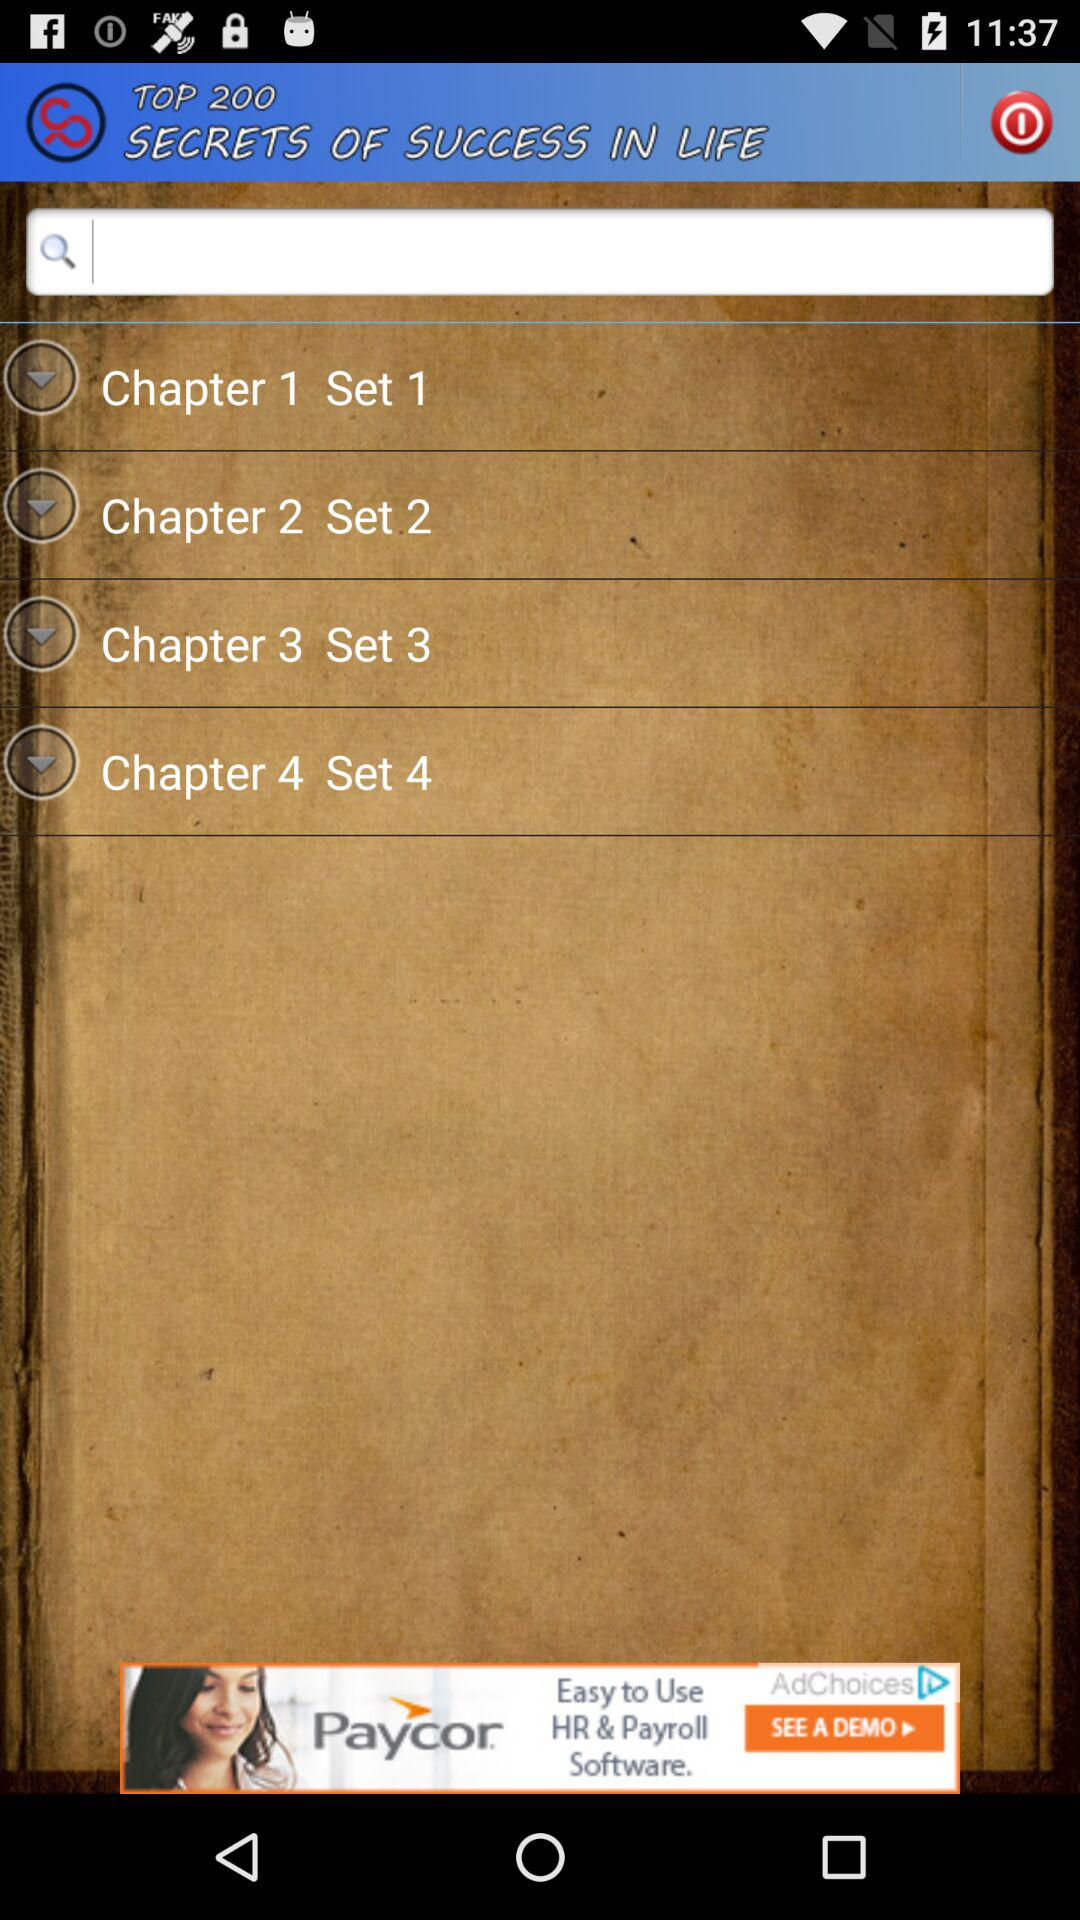What is the set number of "Chapter 1"? The set number for "Chapter 1" is 1. 